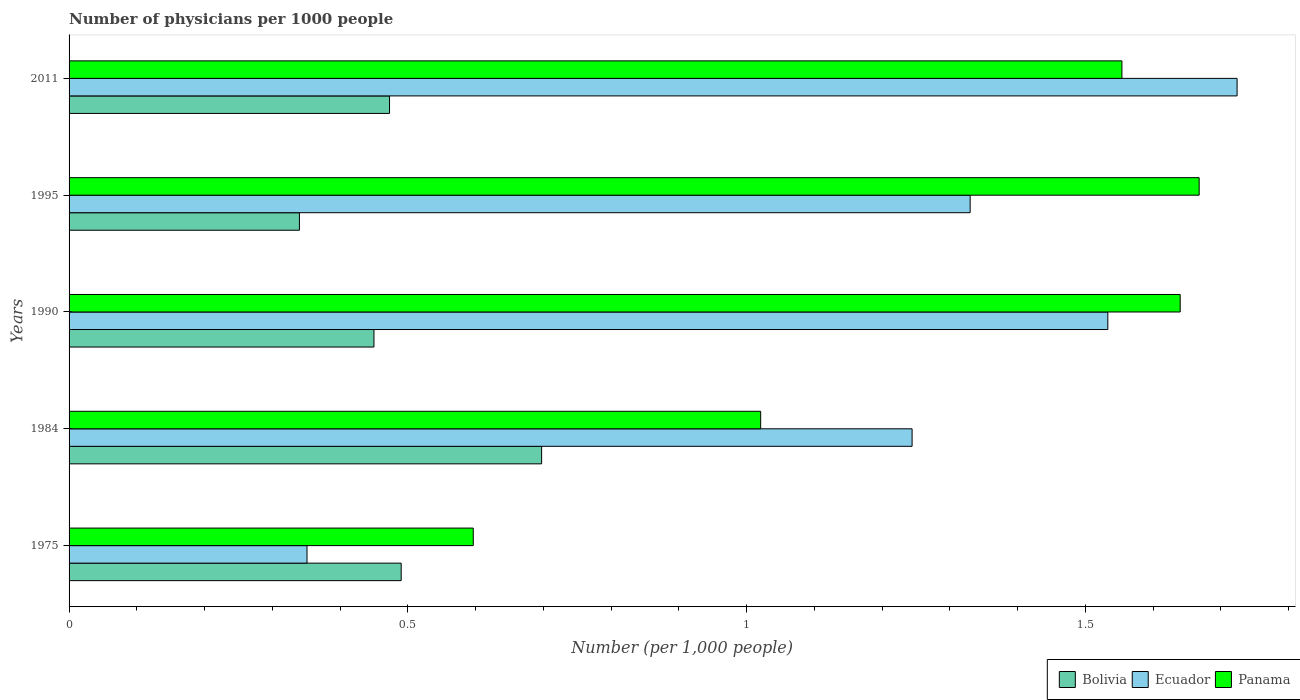How many bars are there on the 2nd tick from the top?
Offer a very short reply. 3. How many bars are there on the 5th tick from the bottom?
Offer a terse response. 3. What is the label of the 1st group of bars from the top?
Provide a succinct answer. 2011. What is the number of physicians in Panama in 2011?
Provide a succinct answer. 1.55. Across all years, what is the maximum number of physicians in Panama?
Offer a very short reply. 1.67. Across all years, what is the minimum number of physicians in Panama?
Offer a terse response. 0.6. In which year was the number of physicians in Bolivia maximum?
Offer a terse response. 1984. In which year was the number of physicians in Panama minimum?
Your response must be concise. 1975. What is the total number of physicians in Bolivia in the graph?
Offer a terse response. 2.45. What is the difference between the number of physicians in Ecuador in 1975 and that in 1984?
Ensure brevity in your answer.  -0.89. What is the difference between the number of physicians in Panama in 2011 and the number of physicians in Bolivia in 1995?
Offer a terse response. 1.21. What is the average number of physicians in Panama per year?
Make the answer very short. 1.3. In the year 1995, what is the difference between the number of physicians in Panama and number of physicians in Ecuador?
Provide a succinct answer. 0.34. In how many years, is the number of physicians in Ecuador greater than 0.6 ?
Make the answer very short. 4. What is the ratio of the number of physicians in Bolivia in 1984 to that in 2011?
Your answer should be very brief. 1.47. What is the difference between the highest and the second highest number of physicians in Panama?
Provide a short and direct response. 0.03. What is the difference between the highest and the lowest number of physicians in Bolivia?
Make the answer very short. 0.36. In how many years, is the number of physicians in Panama greater than the average number of physicians in Panama taken over all years?
Your answer should be very brief. 3. Is the sum of the number of physicians in Bolivia in 1975 and 1990 greater than the maximum number of physicians in Ecuador across all years?
Provide a short and direct response. No. What does the 2nd bar from the top in 2011 represents?
Your answer should be compact. Ecuador. What does the 3rd bar from the bottom in 1995 represents?
Offer a terse response. Panama. Is it the case that in every year, the sum of the number of physicians in Bolivia and number of physicians in Ecuador is greater than the number of physicians in Panama?
Your response must be concise. Yes. How many bars are there?
Keep it short and to the point. 15. What is the difference between two consecutive major ticks on the X-axis?
Give a very brief answer. 0.5. Does the graph contain any zero values?
Provide a short and direct response. No. Does the graph contain grids?
Your answer should be very brief. No. How many legend labels are there?
Ensure brevity in your answer.  3. How are the legend labels stacked?
Your response must be concise. Horizontal. What is the title of the graph?
Make the answer very short. Number of physicians per 1000 people. Does "Bahamas" appear as one of the legend labels in the graph?
Keep it short and to the point. No. What is the label or title of the X-axis?
Make the answer very short. Number (per 1,0 people). What is the Number (per 1,000 people) in Bolivia in 1975?
Your answer should be compact. 0.49. What is the Number (per 1,000 people) of Ecuador in 1975?
Give a very brief answer. 0.35. What is the Number (per 1,000 people) of Panama in 1975?
Provide a short and direct response. 0.6. What is the Number (per 1,000 people) of Bolivia in 1984?
Your response must be concise. 0.7. What is the Number (per 1,000 people) of Ecuador in 1984?
Make the answer very short. 1.24. What is the Number (per 1,000 people) of Panama in 1984?
Keep it short and to the point. 1.02. What is the Number (per 1,000 people) in Bolivia in 1990?
Ensure brevity in your answer.  0.45. What is the Number (per 1,000 people) in Ecuador in 1990?
Provide a short and direct response. 1.53. What is the Number (per 1,000 people) of Panama in 1990?
Your response must be concise. 1.64. What is the Number (per 1,000 people) of Bolivia in 1995?
Offer a very short reply. 0.34. What is the Number (per 1,000 people) of Ecuador in 1995?
Your answer should be very brief. 1.33. What is the Number (per 1,000 people) of Panama in 1995?
Ensure brevity in your answer.  1.67. What is the Number (per 1,000 people) of Bolivia in 2011?
Offer a very short reply. 0.47. What is the Number (per 1,000 people) of Ecuador in 2011?
Offer a very short reply. 1.72. What is the Number (per 1,000 people) of Panama in 2011?
Give a very brief answer. 1.55. Across all years, what is the maximum Number (per 1,000 people) of Bolivia?
Give a very brief answer. 0.7. Across all years, what is the maximum Number (per 1,000 people) of Ecuador?
Provide a short and direct response. 1.72. Across all years, what is the maximum Number (per 1,000 people) of Panama?
Make the answer very short. 1.67. Across all years, what is the minimum Number (per 1,000 people) of Bolivia?
Your answer should be compact. 0.34. Across all years, what is the minimum Number (per 1,000 people) in Ecuador?
Your answer should be very brief. 0.35. Across all years, what is the minimum Number (per 1,000 people) of Panama?
Offer a very short reply. 0.6. What is the total Number (per 1,000 people) of Bolivia in the graph?
Ensure brevity in your answer.  2.45. What is the total Number (per 1,000 people) in Ecuador in the graph?
Provide a short and direct response. 6.18. What is the total Number (per 1,000 people) of Panama in the graph?
Provide a succinct answer. 6.48. What is the difference between the Number (per 1,000 people) in Bolivia in 1975 and that in 1984?
Offer a terse response. -0.21. What is the difference between the Number (per 1,000 people) in Ecuador in 1975 and that in 1984?
Ensure brevity in your answer.  -0.89. What is the difference between the Number (per 1,000 people) of Panama in 1975 and that in 1984?
Keep it short and to the point. -0.42. What is the difference between the Number (per 1,000 people) in Bolivia in 1975 and that in 1990?
Offer a very short reply. 0.04. What is the difference between the Number (per 1,000 people) of Ecuador in 1975 and that in 1990?
Offer a terse response. -1.18. What is the difference between the Number (per 1,000 people) of Panama in 1975 and that in 1990?
Your answer should be compact. -1.04. What is the difference between the Number (per 1,000 people) in Bolivia in 1975 and that in 1995?
Provide a succinct answer. 0.15. What is the difference between the Number (per 1,000 people) in Ecuador in 1975 and that in 1995?
Your response must be concise. -0.98. What is the difference between the Number (per 1,000 people) of Panama in 1975 and that in 1995?
Offer a very short reply. -1.07. What is the difference between the Number (per 1,000 people) of Bolivia in 1975 and that in 2011?
Offer a very short reply. 0.02. What is the difference between the Number (per 1,000 people) of Ecuador in 1975 and that in 2011?
Give a very brief answer. -1.37. What is the difference between the Number (per 1,000 people) in Panama in 1975 and that in 2011?
Your answer should be compact. -0.96. What is the difference between the Number (per 1,000 people) in Bolivia in 1984 and that in 1990?
Your answer should be very brief. 0.25. What is the difference between the Number (per 1,000 people) in Ecuador in 1984 and that in 1990?
Your answer should be compact. -0.29. What is the difference between the Number (per 1,000 people) of Panama in 1984 and that in 1990?
Your answer should be very brief. -0.62. What is the difference between the Number (per 1,000 people) in Bolivia in 1984 and that in 1995?
Keep it short and to the point. 0.36. What is the difference between the Number (per 1,000 people) in Ecuador in 1984 and that in 1995?
Provide a short and direct response. -0.09. What is the difference between the Number (per 1,000 people) in Panama in 1984 and that in 1995?
Ensure brevity in your answer.  -0.65. What is the difference between the Number (per 1,000 people) in Bolivia in 1984 and that in 2011?
Keep it short and to the point. 0.22. What is the difference between the Number (per 1,000 people) of Ecuador in 1984 and that in 2011?
Make the answer very short. -0.48. What is the difference between the Number (per 1,000 people) in Panama in 1984 and that in 2011?
Your answer should be compact. -0.53. What is the difference between the Number (per 1,000 people) in Bolivia in 1990 and that in 1995?
Offer a very short reply. 0.11. What is the difference between the Number (per 1,000 people) in Ecuador in 1990 and that in 1995?
Your response must be concise. 0.2. What is the difference between the Number (per 1,000 people) in Panama in 1990 and that in 1995?
Offer a terse response. -0.03. What is the difference between the Number (per 1,000 people) in Bolivia in 1990 and that in 2011?
Your response must be concise. -0.02. What is the difference between the Number (per 1,000 people) in Ecuador in 1990 and that in 2011?
Your answer should be very brief. -0.19. What is the difference between the Number (per 1,000 people) in Panama in 1990 and that in 2011?
Keep it short and to the point. 0.09. What is the difference between the Number (per 1,000 people) in Bolivia in 1995 and that in 2011?
Provide a short and direct response. -0.13. What is the difference between the Number (per 1,000 people) in Ecuador in 1995 and that in 2011?
Provide a succinct answer. -0.39. What is the difference between the Number (per 1,000 people) in Panama in 1995 and that in 2011?
Offer a terse response. 0.11. What is the difference between the Number (per 1,000 people) in Bolivia in 1975 and the Number (per 1,000 people) in Ecuador in 1984?
Your response must be concise. -0.75. What is the difference between the Number (per 1,000 people) in Bolivia in 1975 and the Number (per 1,000 people) in Panama in 1984?
Make the answer very short. -0.53. What is the difference between the Number (per 1,000 people) of Ecuador in 1975 and the Number (per 1,000 people) of Panama in 1984?
Your answer should be very brief. -0.67. What is the difference between the Number (per 1,000 people) of Bolivia in 1975 and the Number (per 1,000 people) of Ecuador in 1990?
Your answer should be very brief. -1.04. What is the difference between the Number (per 1,000 people) of Bolivia in 1975 and the Number (per 1,000 people) of Panama in 1990?
Your answer should be compact. -1.15. What is the difference between the Number (per 1,000 people) of Ecuador in 1975 and the Number (per 1,000 people) of Panama in 1990?
Offer a terse response. -1.29. What is the difference between the Number (per 1,000 people) of Bolivia in 1975 and the Number (per 1,000 people) of Ecuador in 1995?
Keep it short and to the point. -0.84. What is the difference between the Number (per 1,000 people) of Bolivia in 1975 and the Number (per 1,000 people) of Panama in 1995?
Offer a terse response. -1.18. What is the difference between the Number (per 1,000 people) of Ecuador in 1975 and the Number (per 1,000 people) of Panama in 1995?
Offer a very short reply. -1.32. What is the difference between the Number (per 1,000 people) of Bolivia in 1975 and the Number (per 1,000 people) of Ecuador in 2011?
Keep it short and to the point. -1.23. What is the difference between the Number (per 1,000 people) of Bolivia in 1975 and the Number (per 1,000 people) of Panama in 2011?
Provide a short and direct response. -1.06. What is the difference between the Number (per 1,000 people) in Ecuador in 1975 and the Number (per 1,000 people) in Panama in 2011?
Your response must be concise. -1.2. What is the difference between the Number (per 1,000 people) of Bolivia in 1984 and the Number (per 1,000 people) of Ecuador in 1990?
Provide a succinct answer. -0.84. What is the difference between the Number (per 1,000 people) in Bolivia in 1984 and the Number (per 1,000 people) in Panama in 1990?
Ensure brevity in your answer.  -0.94. What is the difference between the Number (per 1,000 people) of Ecuador in 1984 and the Number (per 1,000 people) of Panama in 1990?
Provide a short and direct response. -0.4. What is the difference between the Number (per 1,000 people) in Bolivia in 1984 and the Number (per 1,000 people) in Ecuador in 1995?
Your answer should be compact. -0.63. What is the difference between the Number (per 1,000 people) in Bolivia in 1984 and the Number (per 1,000 people) in Panama in 1995?
Your response must be concise. -0.97. What is the difference between the Number (per 1,000 people) of Ecuador in 1984 and the Number (per 1,000 people) of Panama in 1995?
Make the answer very short. -0.42. What is the difference between the Number (per 1,000 people) in Bolivia in 1984 and the Number (per 1,000 people) in Ecuador in 2011?
Make the answer very short. -1.03. What is the difference between the Number (per 1,000 people) of Bolivia in 1984 and the Number (per 1,000 people) of Panama in 2011?
Ensure brevity in your answer.  -0.86. What is the difference between the Number (per 1,000 people) of Ecuador in 1984 and the Number (per 1,000 people) of Panama in 2011?
Make the answer very short. -0.31. What is the difference between the Number (per 1,000 people) of Bolivia in 1990 and the Number (per 1,000 people) of Ecuador in 1995?
Keep it short and to the point. -0.88. What is the difference between the Number (per 1,000 people) of Bolivia in 1990 and the Number (per 1,000 people) of Panama in 1995?
Keep it short and to the point. -1.22. What is the difference between the Number (per 1,000 people) of Ecuador in 1990 and the Number (per 1,000 people) of Panama in 1995?
Your response must be concise. -0.13. What is the difference between the Number (per 1,000 people) in Bolivia in 1990 and the Number (per 1,000 people) in Ecuador in 2011?
Make the answer very short. -1.27. What is the difference between the Number (per 1,000 people) in Bolivia in 1990 and the Number (per 1,000 people) in Panama in 2011?
Your answer should be compact. -1.1. What is the difference between the Number (per 1,000 people) of Ecuador in 1990 and the Number (per 1,000 people) of Panama in 2011?
Your response must be concise. -0.02. What is the difference between the Number (per 1,000 people) in Bolivia in 1995 and the Number (per 1,000 people) in Ecuador in 2011?
Provide a short and direct response. -1.38. What is the difference between the Number (per 1,000 people) of Bolivia in 1995 and the Number (per 1,000 people) of Panama in 2011?
Your response must be concise. -1.21. What is the difference between the Number (per 1,000 people) in Ecuador in 1995 and the Number (per 1,000 people) in Panama in 2011?
Give a very brief answer. -0.22. What is the average Number (per 1,000 people) of Bolivia per year?
Provide a succinct answer. 0.49. What is the average Number (per 1,000 people) in Ecuador per year?
Keep it short and to the point. 1.24. What is the average Number (per 1,000 people) in Panama per year?
Your answer should be very brief. 1.3. In the year 1975, what is the difference between the Number (per 1,000 people) in Bolivia and Number (per 1,000 people) in Ecuador?
Offer a very short reply. 0.14. In the year 1975, what is the difference between the Number (per 1,000 people) of Bolivia and Number (per 1,000 people) of Panama?
Give a very brief answer. -0.11. In the year 1975, what is the difference between the Number (per 1,000 people) in Ecuador and Number (per 1,000 people) in Panama?
Provide a succinct answer. -0.25. In the year 1984, what is the difference between the Number (per 1,000 people) of Bolivia and Number (per 1,000 people) of Ecuador?
Provide a short and direct response. -0.55. In the year 1984, what is the difference between the Number (per 1,000 people) of Bolivia and Number (per 1,000 people) of Panama?
Make the answer very short. -0.32. In the year 1984, what is the difference between the Number (per 1,000 people) of Ecuador and Number (per 1,000 people) of Panama?
Keep it short and to the point. 0.22. In the year 1990, what is the difference between the Number (per 1,000 people) in Bolivia and Number (per 1,000 people) in Ecuador?
Your answer should be compact. -1.08. In the year 1990, what is the difference between the Number (per 1,000 people) in Bolivia and Number (per 1,000 people) in Panama?
Provide a succinct answer. -1.19. In the year 1990, what is the difference between the Number (per 1,000 people) in Ecuador and Number (per 1,000 people) in Panama?
Keep it short and to the point. -0.11. In the year 1995, what is the difference between the Number (per 1,000 people) of Bolivia and Number (per 1,000 people) of Ecuador?
Offer a terse response. -0.99. In the year 1995, what is the difference between the Number (per 1,000 people) in Bolivia and Number (per 1,000 people) in Panama?
Offer a terse response. -1.33. In the year 1995, what is the difference between the Number (per 1,000 people) of Ecuador and Number (per 1,000 people) of Panama?
Your answer should be very brief. -0.34. In the year 2011, what is the difference between the Number (per 1,000 people) in Bolivia and Number (per 1,000 people) in Ecuador?
Offer a very short reply. -1.25. In the year 2011, what is the difference between the Number (per 1,000 people) in Bolivia and Number (per 1,000 people) in Panama?
Offer a very short reply. -1.08. In the year 2011, what is the difference between the Number (per 1,000 people) of Ecuador and Number (per 1,000 people) of Panama?
Ensure brevity in your answer.  0.17. What is the ratio of the Number (per 1,000 people) in Bolivia in 1975 to that in 1984?
Make the answer very short. 0.7. What is the ratio of the Number (per 1,000 people) of Ecuador in 1975 to that in 1984?
Provide a succinct answer. 0.28. What is the ratio of the Number (per 1,000 people) in Panama in 1975 to that in 1984?
Give a very brief answer. 0.58. What is the ratio of the Number (per 1,000 people) in Bolivia in 1975 to that in 1990?
Keep it short and to the point. 1.09. What is the ratio of the Number (per 1,000 people) in Ecuador in 1975 to that in 1990?
Provide a short and direct response. 0.23. What is the ratio of the Number (per 1,000 people) in Panama in 1975 to that in 1990?
Provide a succinct answer. 0.36. What is the ratio of the Number (per 1,000 people) in Bolivia in 1975 to that in 1995?
Offer a terse response. 1.44. What is the ratio of the Number (per 1,000 people) of Ecuador in 1975 to that in 1995?
Make the answer very short. 0.26. What is the ratio of the Number (per 1,000 people) in Panama in 1975 to that in 1995?
Your response must be concise. 0.36. What is the ratio of the Number (per 1,000 people) of Bolivia in 1975 to that in 2011?
Ensure brevity in your answer.  1.04. What is the ratio of the Number (per 1,000 people) in Ecuador in 1975 to that in 2011?
Provide a succinct answer. 0.2. What is the ratio of the Number (per 1,000 people) in Panama in 1975 to that in 2011?
Provide a short and direct response. 0.38. What is the ratio of the Number (per 1,000 people) in Bolivia in 1984 to that in 1990?
Your answer should be compact. 1.55. What is the ratio of the Number (per 1,000 people) in Ecuador in 1984 to that in 1990?
Your response must be concise. 0.81. What is the ratio of the Number (per 1,000 people) in Panama in 1984 to that in 1990?
Keep it short and to the point. 0.62. What is the ratio of the Number (per 1,000 people) in Bolivia in 1984 to that in 1995?
Provide a succinct answer. 2.05. What is the ratio of the Number (per 1,000 people) in Ecuador in 1984 to that in 1995?
Your answer should be compact. 0.94. What is the ratio of the Number (per 1,000 people) of Panama in 1984 to that in 1995?
Your response must be concise. 0.61. What is the ratio of the Number (per 1,000 people) of Bolivia in 1984 to that in 2011?
Give a very brief answer. 1.47. What is the ratio of the Number (per 1,000 people) in Ecuador in 1984 to that in 2011?
Give a very brief answer. 0.72. What is the ratio of the Number (per 1,000 people) in Panama in 1984 to that in 2011?
Your response must be concise. 0.66. What is the ratio of the Number (per 1,000 people) of Bolivia in 1990 to that in 1995?
Your answer should be very brief. 1.32. What is the ratio of the Number (per 1,000 people) of Ecuador in 1990 to that in 1995?
Keep it short and to the point. 1.15. What is the ratio of the Number (per 1,000 people) in Panama in 1990 to that in 1995?
Provide a short and direct response. 0.98. What is the ratio of the Number (per 1,000 people) of Bolivia in 1990 to that in 2011?
Provide a succinct answer. 0.95. What is the ratio of the Number (per 1,000 people) in Ecuador in 1990 to that in 2011?
Keep it short and to the point. 0.89. What is the ratio of the Number (per 1,000 people) of Panama in 1990 to that in 2011?
Your response must be concise. 1.06. What is the ratio of the Number (per 1,000 people) of Bolivia in 1995 to that in 2011?
Make the answer very short. 0.72. What is the ratio of the Number (per 1,000 people) of Ecuador in 1995 to that in 2011?
Offer a terse response. 0.77. What is the ratio of the Number (per 1,000 people) of Panama in 1995 to that in 2011?
Your answer should be compact. 1.07. What is the difference between the highest and the second highest Number (per 1,000 people) in Bolivia?
Offer a terse response. 0.21. What is the difference between the highest and the second highest Number (per 1,000 people) of Ecuador?
Your response must be concise. 0.19. What is the difference between the highest and the second highest Number (per 1,000 people) in Panama?
Offer a terse response. 0.03. What is the difference between the highest and the lowest Number (per 1,000 people) in Bolivia?
Make the answer very short. 0.36. What is the difference between the highest and the lowest Number (per 1,000 people) in Ecuador?
Make the answer very short. 1.37. What is the difference between the highest and the lowest Number (per 1,000 people) of Panama?
Keep it short and to the point. 1.07. 